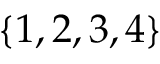<formula> <loc_0><loc_0><loc_500><loc_500>\{ 1 , 2 , 3 , 4 \}</formula> 